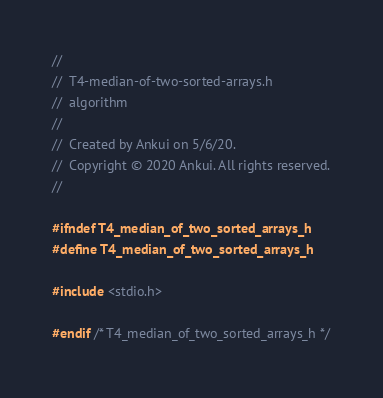<code> <loc_0><loc_0><loc_500><loc_500><_C_>//
//  T4-median-of-two-sorted-arrays.h
//  algorithm
//
//  Created by Ankui on 5/6/20.
//  Copyright © 2020 Ankui. All rights reserved.
//

#ifndef T4_median_of_two_sorted_arrays_h
#define T4_median_of_two_sorted_arrays_h

#include <stdio.h>

#endif /* T4_median_of_two_sorted_arrays_h */
</code> 